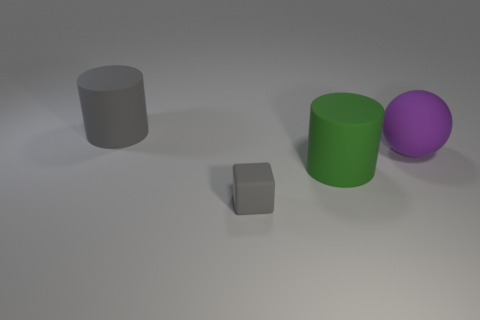There is a large cylinder that is behind the green object; what material is it?
Your answer should be very brief. Rubber. Is the number of large purple things that are behind the purple thing less than the number of matte balls?
Your answer should be compact. Yes. Is the shape of the tiny object the same as the purple thing?
Your response must be concise. No. Are there any other things that have the same shape as the purple thing?
Keep it short and to the point. No. Are there any large brown cubes?
Offer a very short reply. No. There is a small object; is its shape the same as the large matte thing that is to the left of the tiny thing?
Offer a very short reply. No. The cylinder to the right of the big cylinder behind the big green cylinder is made of what material?
Provide a succinct answer. Rubber. What is the color of the cube?
Offer a terse response. Gray. Does the big rubber thing behind the purple thing have the same color as the big thing that is in front of the rubber ball?
Give a very brief answer. No. What size is the green rubber object that is the same shape as the big gray thing?
Give a very brief answer. Large. 